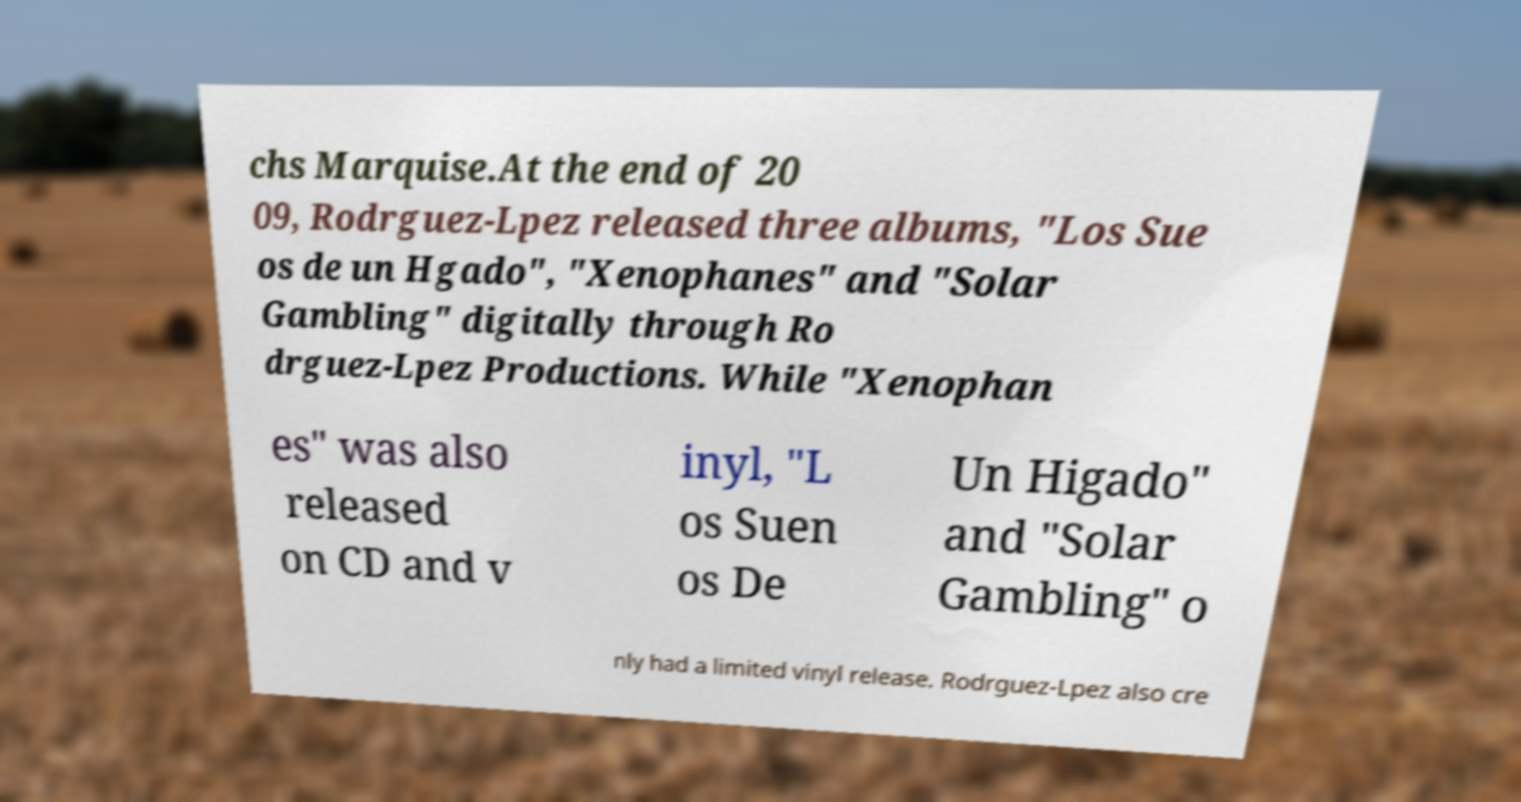Can you read and provide the text displayed in the image?This photo seems to have some interesting text. Can you extract and type it out for me? chs Marquise.At the end of 20 09, Rodrguez-Lpez released three albums, "Los Sue os de un Hgado", "Xenophanes" and "Solar Gambling" digitally through Ro drguez-Lpez Productions. While "Xenophan es" was also released on CD and v inyl, "L os Suen os De Un Higado" and "Solar Gambling" o nly had a limited vinyl release. Rodrguez-Lpez also cre 